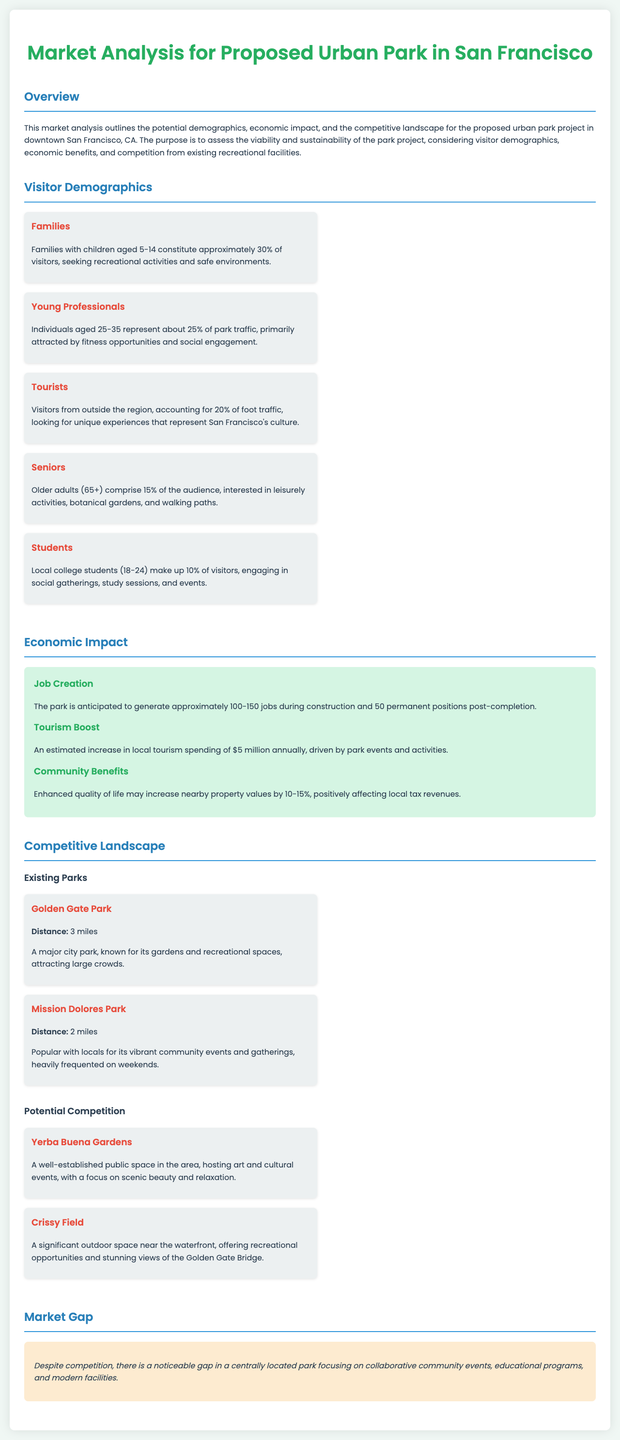What percentage of visitors are families? The document states that families with children aged 5-14 constitute approximately 30% of visitors.
Answer: 30% What is the estimated annual increase in local tourism spending? The report mentions an estimated increase in local tourism spending of $5 million annually due to park events and activities.
Answer: $5 million How many jobs are anticipated to be created during construction? According to the economic impact section, the park is anticipated to generate approximately 100-150 jobs during construction.
Answer: 100-150 What demographic represents about 25% of park traffic? The document identifies young professionals aged 25-35 as representing about 25% of park traffic.
Answer: Young Professionals What is a major competitive park located 3 miles away? The report lists Golden Gate Park as a major city park located 3 miles away from the proposed urban park.
Answer: Golden Gate Park What community benefit is expected to increase property values by? The report suggests that enhanced quality of life may increase nearby property values by 10-15%.
Answer: 10-15% What gap does the document highlight in the competitive landscape? The document mentions a gap focusing on collaborative community events, educational programs, and modern facilities despite competition.
Answer: Collaborative community events Which group constitutes 10% of visitors to the park? Local college students aged 18-24 make up 10% of visitors.
Answer: Students 